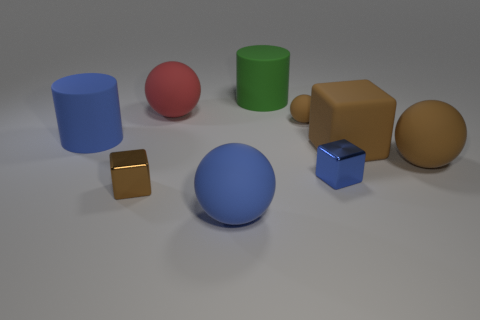There is a small matte thing that is the same shape as the big red rubber thing; what color is it? The small matte object that shares its shape with the large red sphere is gold in color. 